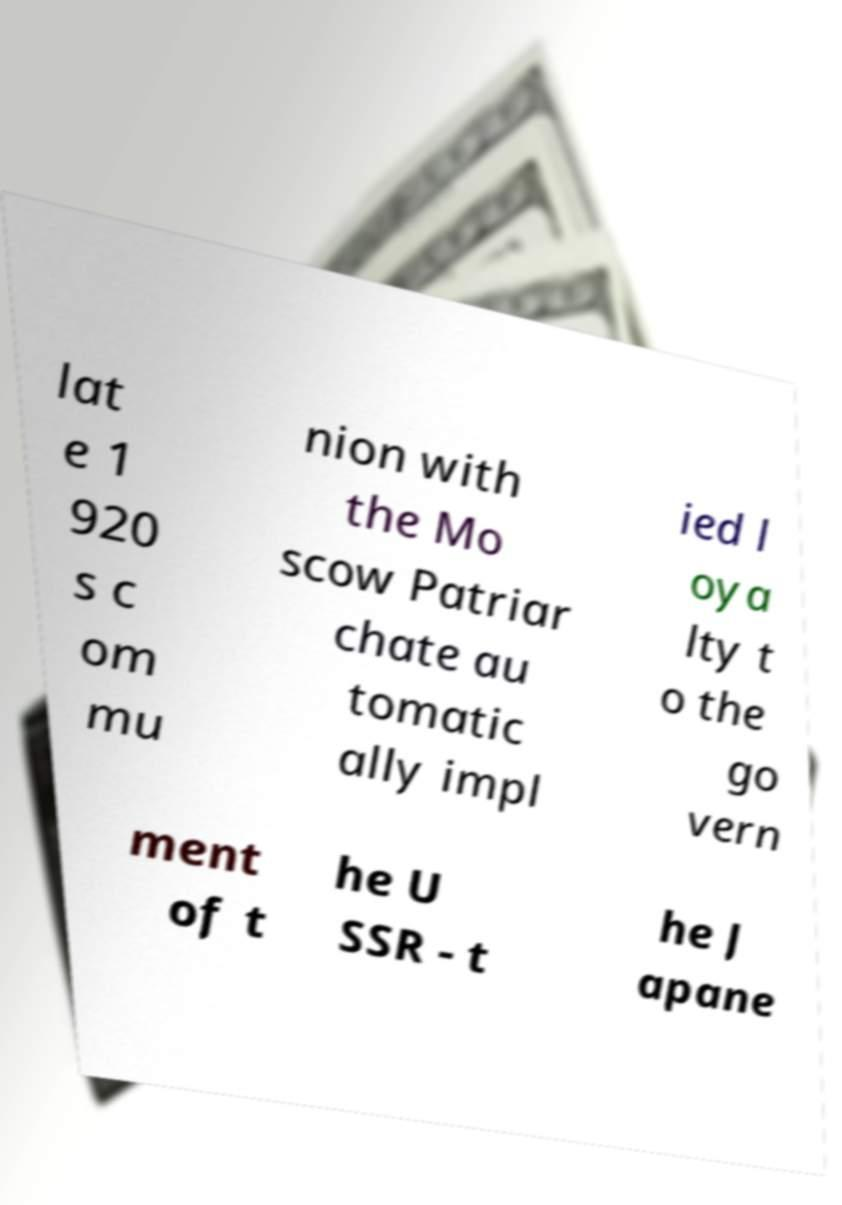What messages or text are displayed in this image? I need them in a readable, typed format. lat e 1 920 s c om mu nion with the Mo scow Patriar chate au tomatic ally impl ied l oya lty t o the go vern ment of t he U SSR - t he J apane 